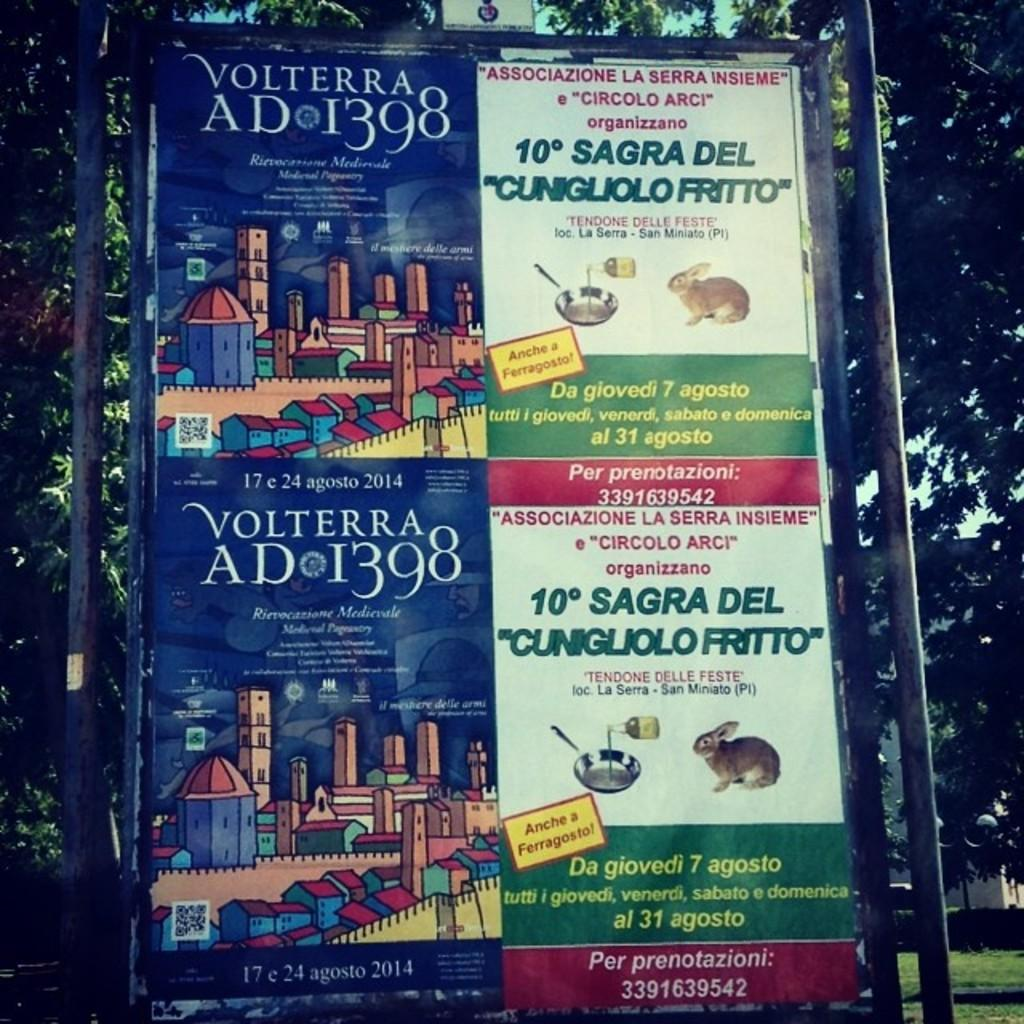<image>
Write a terse but informative summary of the picture. A book titled Volterra is next to another book. 